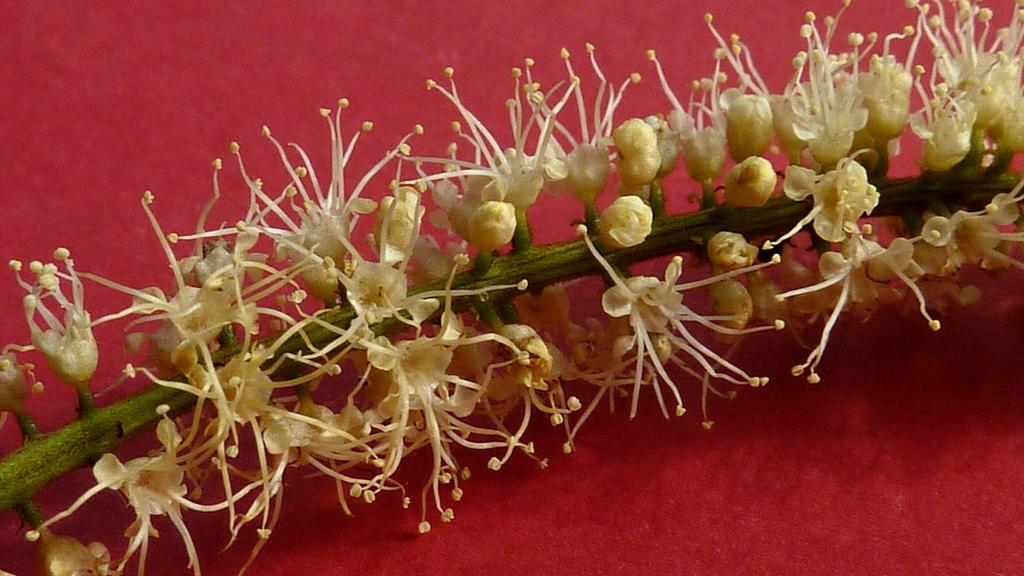What type of plant is visible in the image? There are flowers on a plant in the image. Where is the plant located? The plant is on a table. What type of actor is performing under the tent in the image? There is no actor or tent present in the image; it features a plant with flowers on a table. What is the hammer used for in the image? There is no hammer present in the image. 